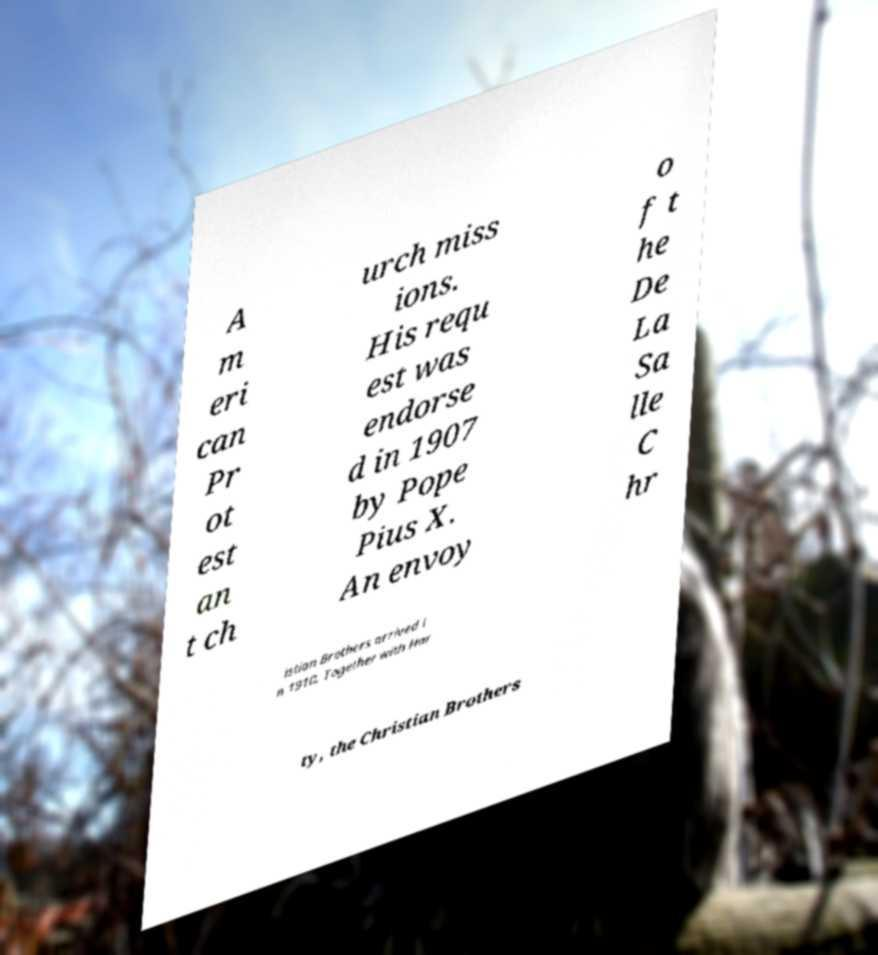I need the written content from this picture converted into text. Can you do that? A m eri can Pr ot est an t ch urch miss ions. His requ est was endorse d in 1907 by Pope Pius X. An envoy o f t he De La Sa lle C hr istian Brothers arrived i n 1910. Together with Har ty, the Christian Brothers 